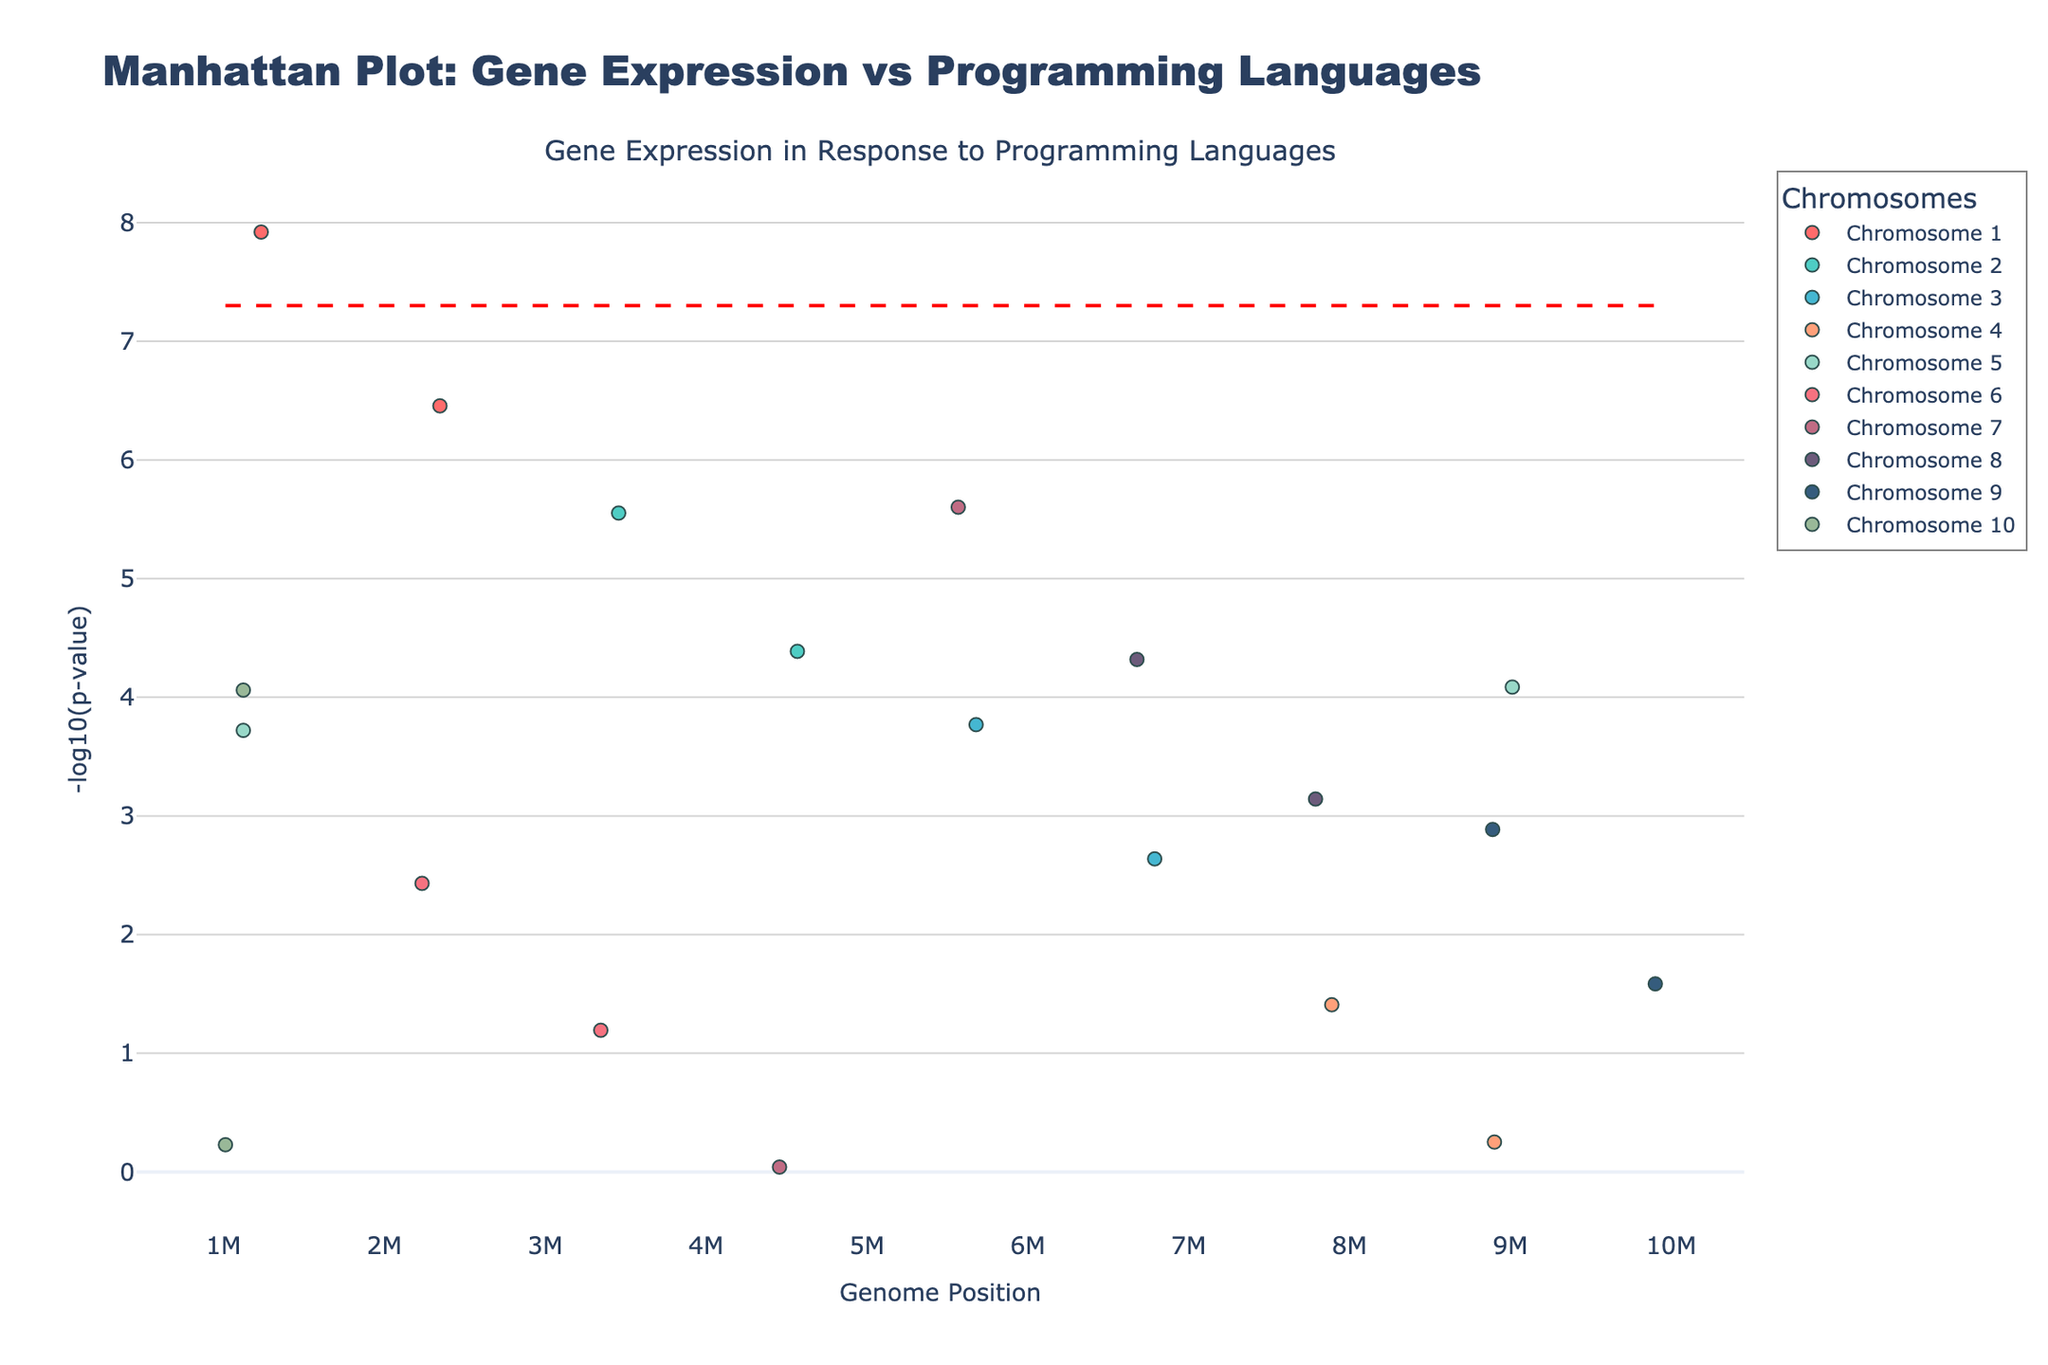Which chromosome has the most significant p-value? To determine the most significant p-value, we need to find the highest -log10(p-value) on the y-axis of the Manhattan Plot. The data point with the highest -log10(p-value) corresponds to Chromosome 1 for the gene BRCA1 with a p-value of 1.2e-8.
Answer: Chromosome 1 What gene has the smallest p-value on Chromosome 5? The smallest p-value on Chromosome 5 is represented by the highest -log10(p-value) value on the y-axis for that particular chromosome. For Chromosome 5, NRAS has the smallest p-value (or highest -log10(p-value)), which is 8.2e-5.
Answer: NRAS How many genes on Chromosome 2 have a p-value less than 1e-5? Looking at the plot and observing the -log10(p-value) threshold line, we see that Chromosome 2 has data points representing two genes: EGFR and KRAS. Neither has a -log10(p-value) higher than that of 1e-5 (roughly 5 on the y-axis).
Answer: 0 Which gene expressions resulted from exposure to Rust and what are their p-values? Identifying the color and position linked to Rust shows the gene SMAD4 on Chromosome 7. Its p-value translates to -log10(9.1e-1) on the plot.
Answer: SMAD4, 9.1e-1 Compare the p-values between ATM (PHP) on Chromosome 7 and IDH1 (Groovy) on Chromosome 10, which gene has the lower p-value? Look at the y-axis values of these genes' data points. ATM on Chromosome 7 has a -log10(p-value) = -log10(2.5e-6), and IDH1 on Chromosome 10 has a -log10(p-value) = -log10(8.7e-5). Since ATM's -log10(p-value) is higher, ATM has a smaller (more significant) p-value.
Answer: ATM How many data points have a p-value less than the threshold line (5e-8)? The threshold line on the plot corresponds to -log10(5e-8). By counting the data points with a -log10(p-value) above this line, we find one gene (BRCA1 on Chromosome 1).
Answer: 1 What is the position of the data point with the lowest -log10(p-value) on the plot? The lowest -log10(p-value) on the plot corresponds to the highest p-value, represented by SMAD4 on Chromosome 7 with a p-value of 9.1e-1 (position 4456789).
Answer: 4456789 Which gene experiences the most significant change in expression (p-value) on Chromosome 3? To determine the most significant change, look at the highest -log10(p-value) data point for Chromosome 3. PTEN, with a p-value of 1.7e-4, is more significant compared to APC.
Answer: PTEN 